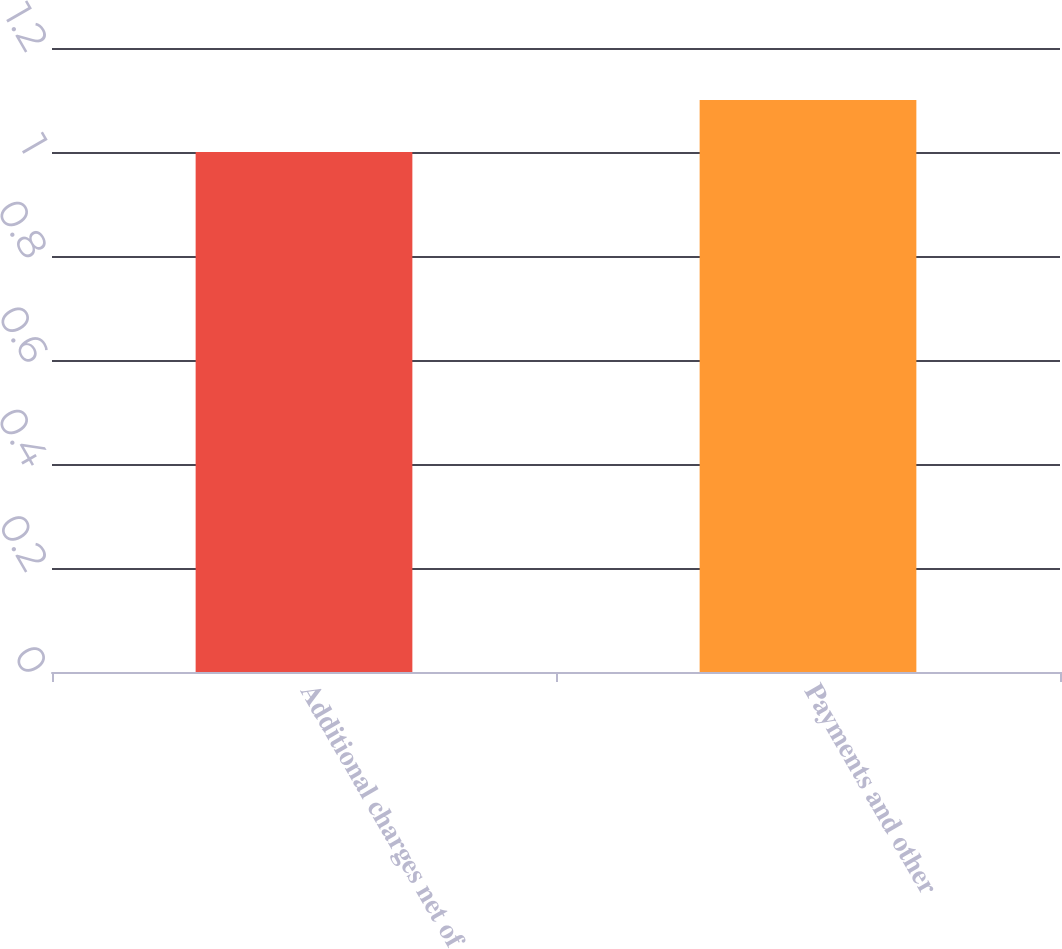<chart> <loc_0><loc_0><loc_500><loc_500><bar_chart><fcel>Additional charges net of<fcel>Payments and other<nl><fcel>1<fcel>1.1<nl></chart> 